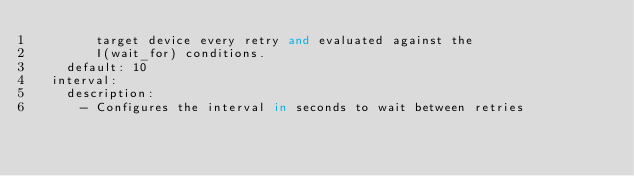<code> <loc_0><loc_0><loc_500><loc_500><_Python_>        target device every retry and evaluated against the
        I(wait_for) conditions.
    default: 10
  interval:
    description:
      - Configures the interval in seconds to wait between retries</code> 